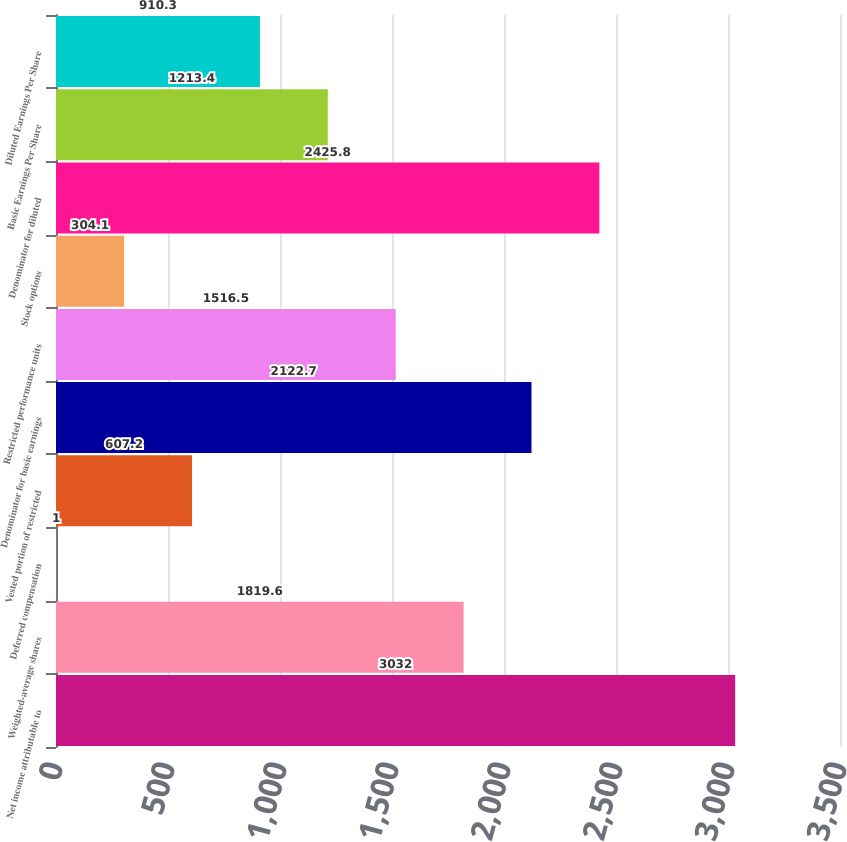Convert chart to OTSL. <chart><loc_0><loc_0><loc_500><loc_500><bar_chart><fcel>Net income attributable to<fcel>Weighted-average shares<fcel>Deferred compensation<fcel>Vested portion of restricted<fcel>Denominator for basic earnings<fcel>Restricted performance units<fcel>Stock options<fcel>Denominator for diluted<fcel>Basic Earnings Per Share<fcel>Diluted Earnings Per Share<nl><fcel>3032<fcel>1819.6<fcel>1<fcel>607.2<fcel>2122.7<fcel>1516.5<fcel>304.1<fcel>2425.8<fcel>1213.4<fcel>910.3<nl></chart> 